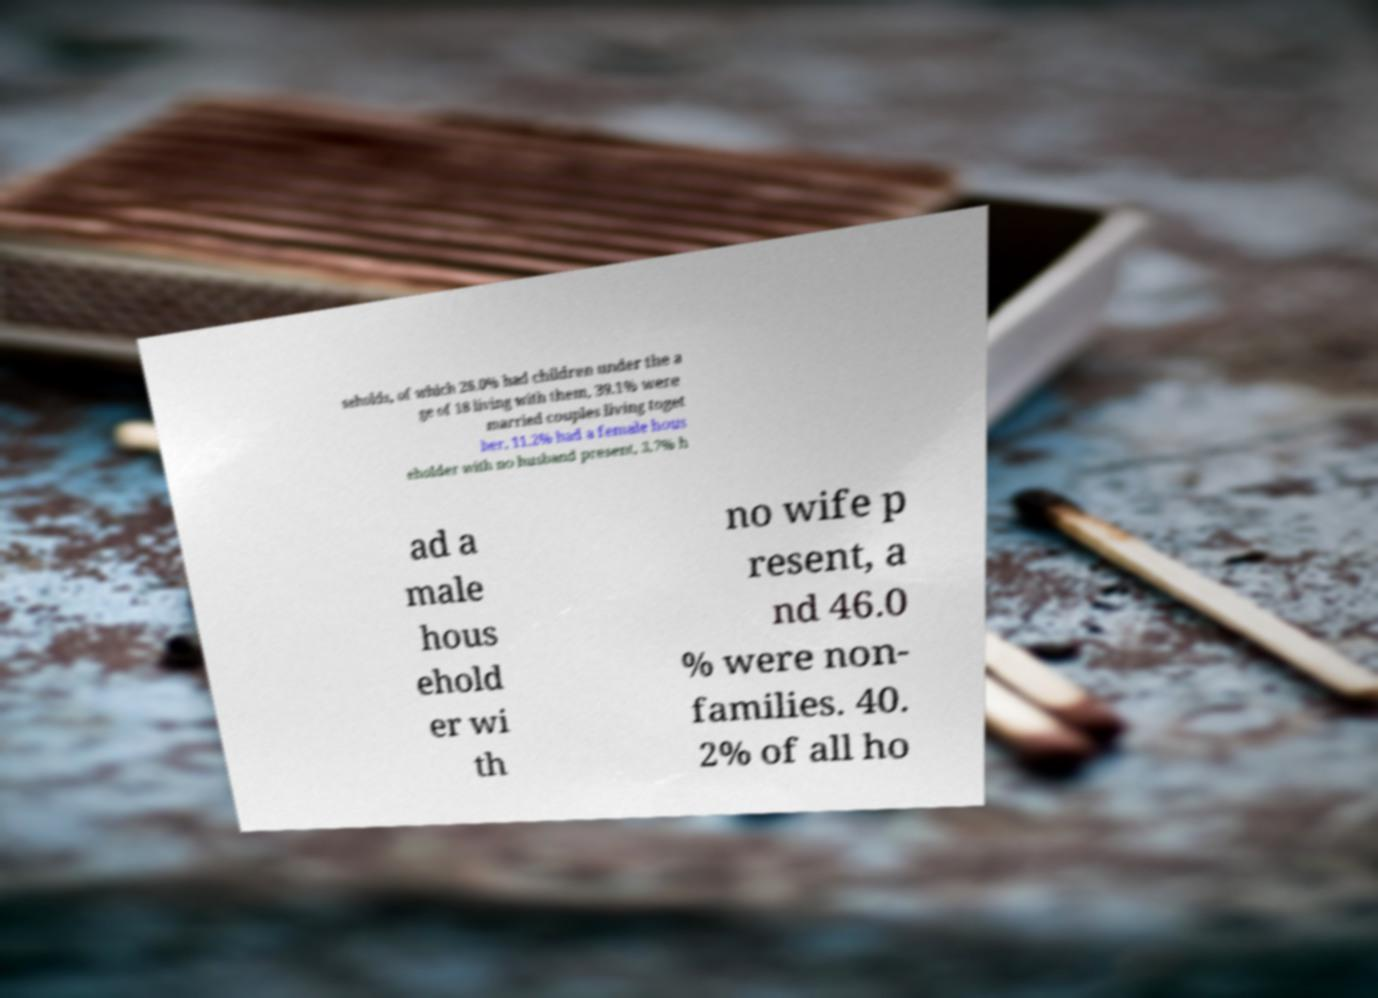Could you assist in decoding the text presented in this image and type it out clearly? seholds, of which 26.0% had children under the a ge of 18 living with them, 39.1% were married couples living toget her, 11.2% had a female hous eholder with no husband present, 3.7% h ad a male hous ehold er wi th no wife p resent, a nd 46.0 % were non- families. 40. 2% of all ho 